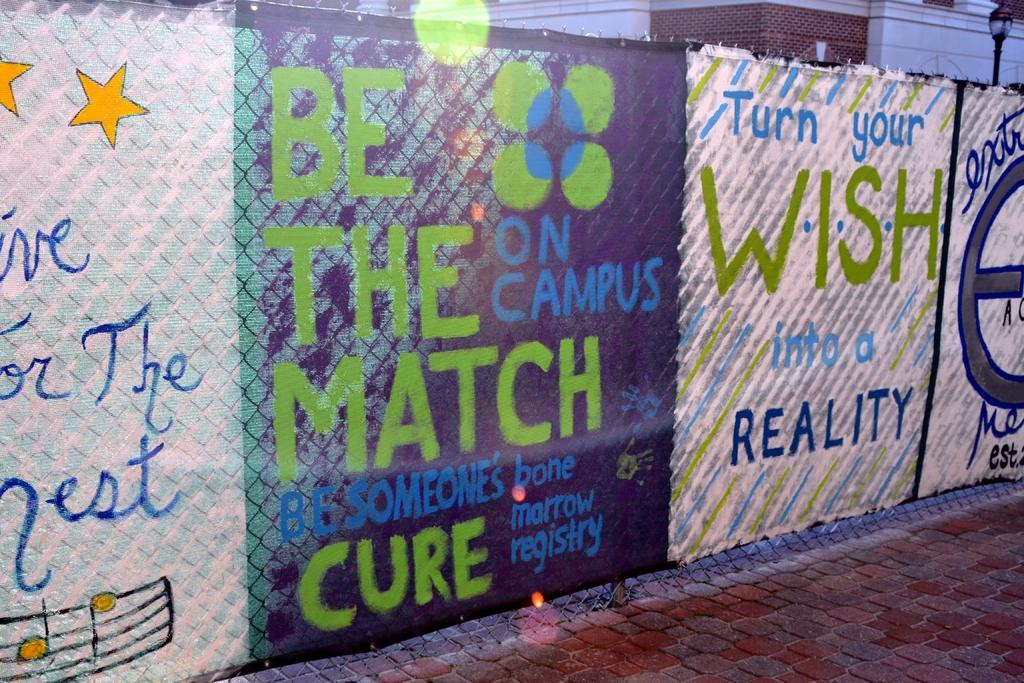What should you turn into reality?
Make the answer very short. Wish. 